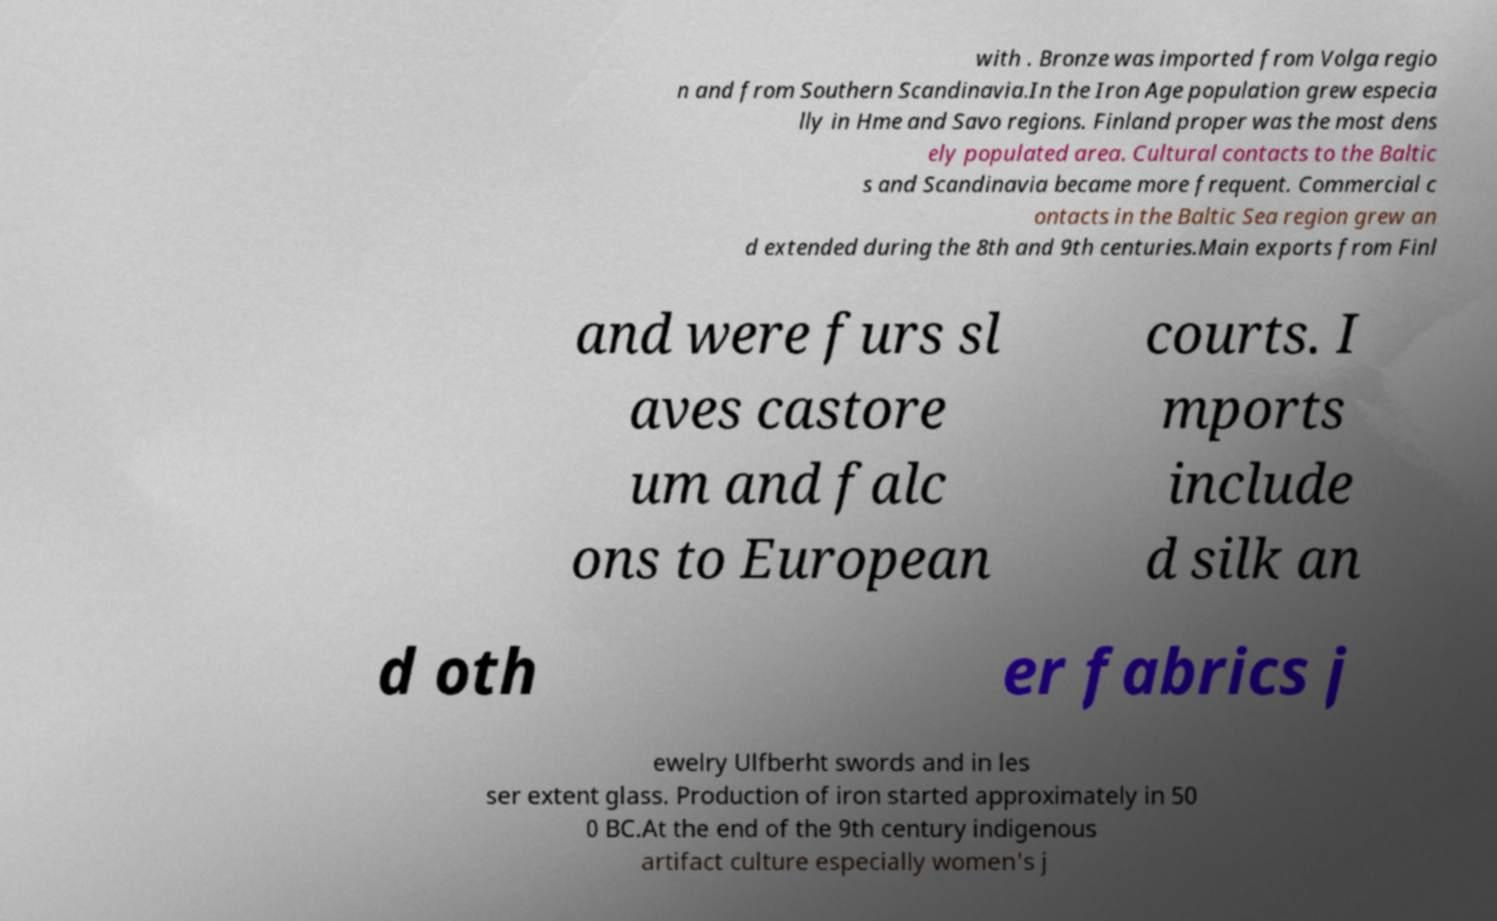Please identify and transcribe the text found in this image. with . Bronze was imported from Volga regio n and from Southern Scandinavia.In the Iron Age population grew especia lly in Hme and Savo regions. Finland proper was the most dens ely populated area. Cultural contacts to the Baltic s and Scandinavia became more frequent. Commercial c ontacts in the Baltic Sea region grew an d extended during the 8th and 9th centuries.Main exports from Finl and were furs sl aves castore um and falc ons to European courts. I mports include d silk an d oth er fabrics j ewelry Ulfberht swords and in les ser extent glass. Production of iron started approximately in 50 0 BC.At the end of the 9th century indigenous artifact culture especially women's j 